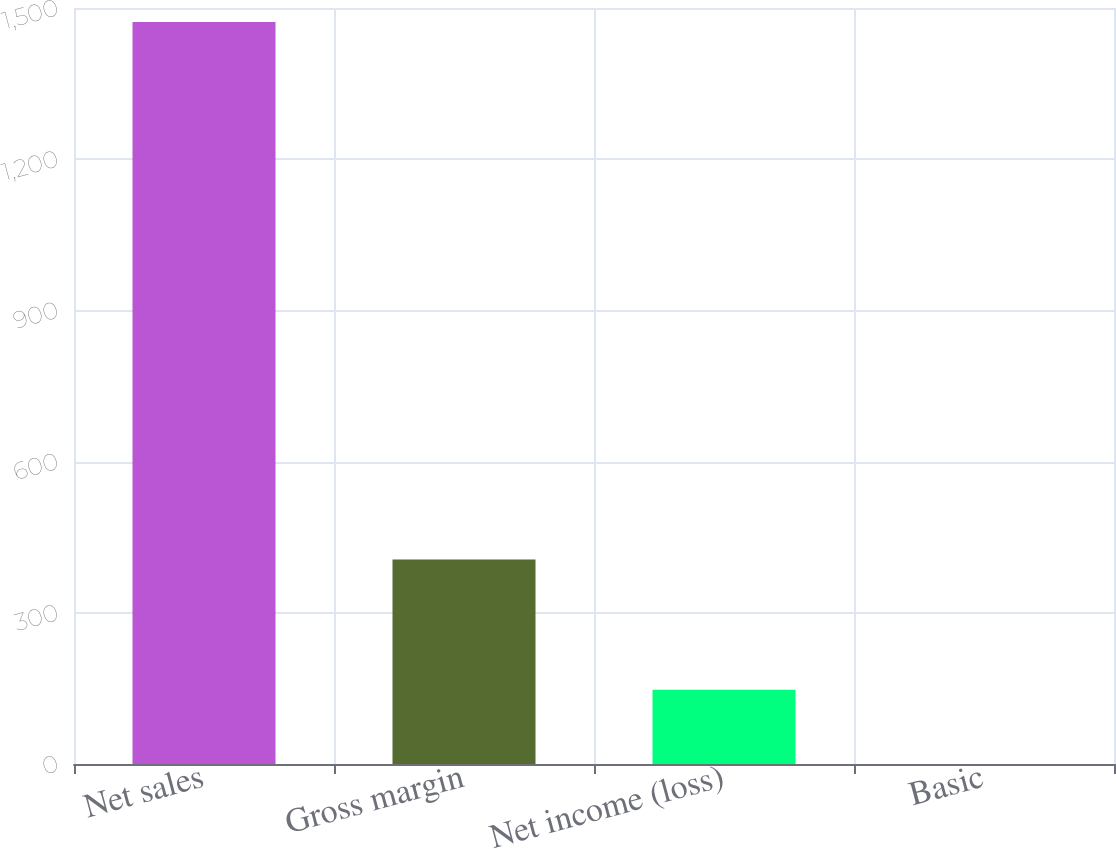Convert chart to OTSL. <chart><loc_0><loc_0><loc_500><loc_500><bar_chart><fcel>Net sales<fcel>Gross margin<fcel>Net income (loss)<fcel>Basic<nl><fcel>1472<fcel>406<fcel>147.22<fcel>0.02<nl></chart> 